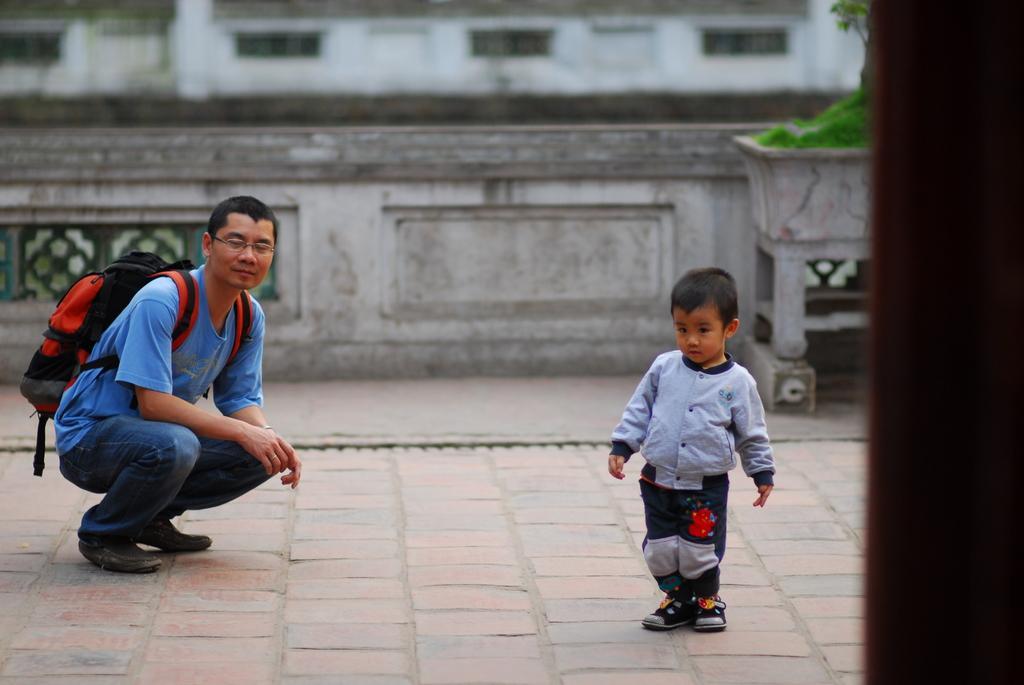Can you describe this image briefly? In this picture I can see a man and a boy, man wore a backpack and I can see a plant in the pot on the right side of the picture and I can see building in the back. 